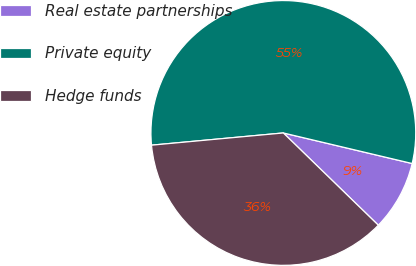Convert chart to OTSL. <chart><loc_0><loc_0><loc_500><loc_500><pie_chart><fcel>Real estate partnerships<fcel>Private equity<fcel>Hedge funds<nl><fcel>8.56%<fcel>55.18%<fcel>36.26%<nl></chart> 